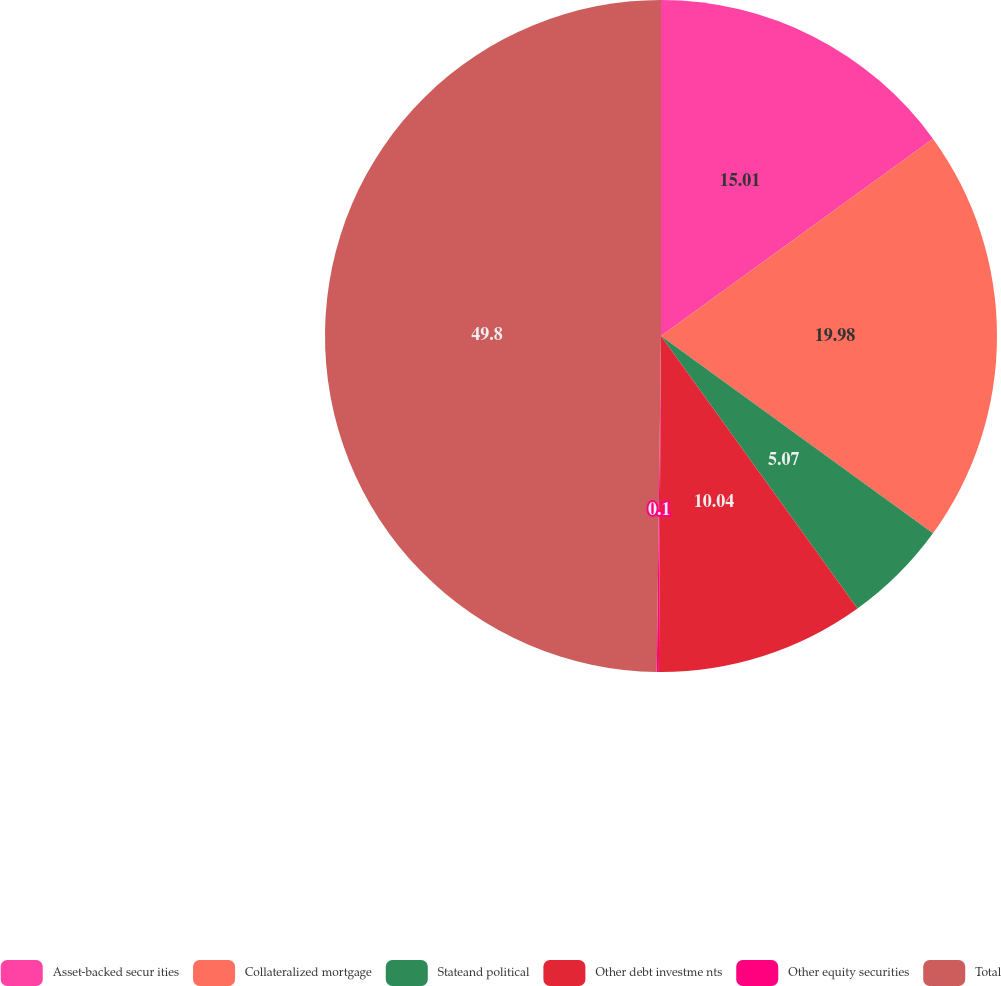Convert chart. <chart><loc_0><loc_0><loc_500><loc_500><pie_chart><fcel>Asset-backed secur ities<fcel>Collateralized mortgage<fcel>Stateand political<fcel>Other debt investme nts<fcel>Other equity securities<fcel>Total<nl><fcel>15.01%<fcel>19.98%<fcel>5.07%<fcel>10.04%<fcel>0.1%<fcel>49.8%<nl></chart> 